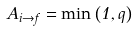<formula> <loc_0><loc_0><loc_500><loc_500>A _ { i \to f } = \min \left ( 1 , q \right )</formula> 